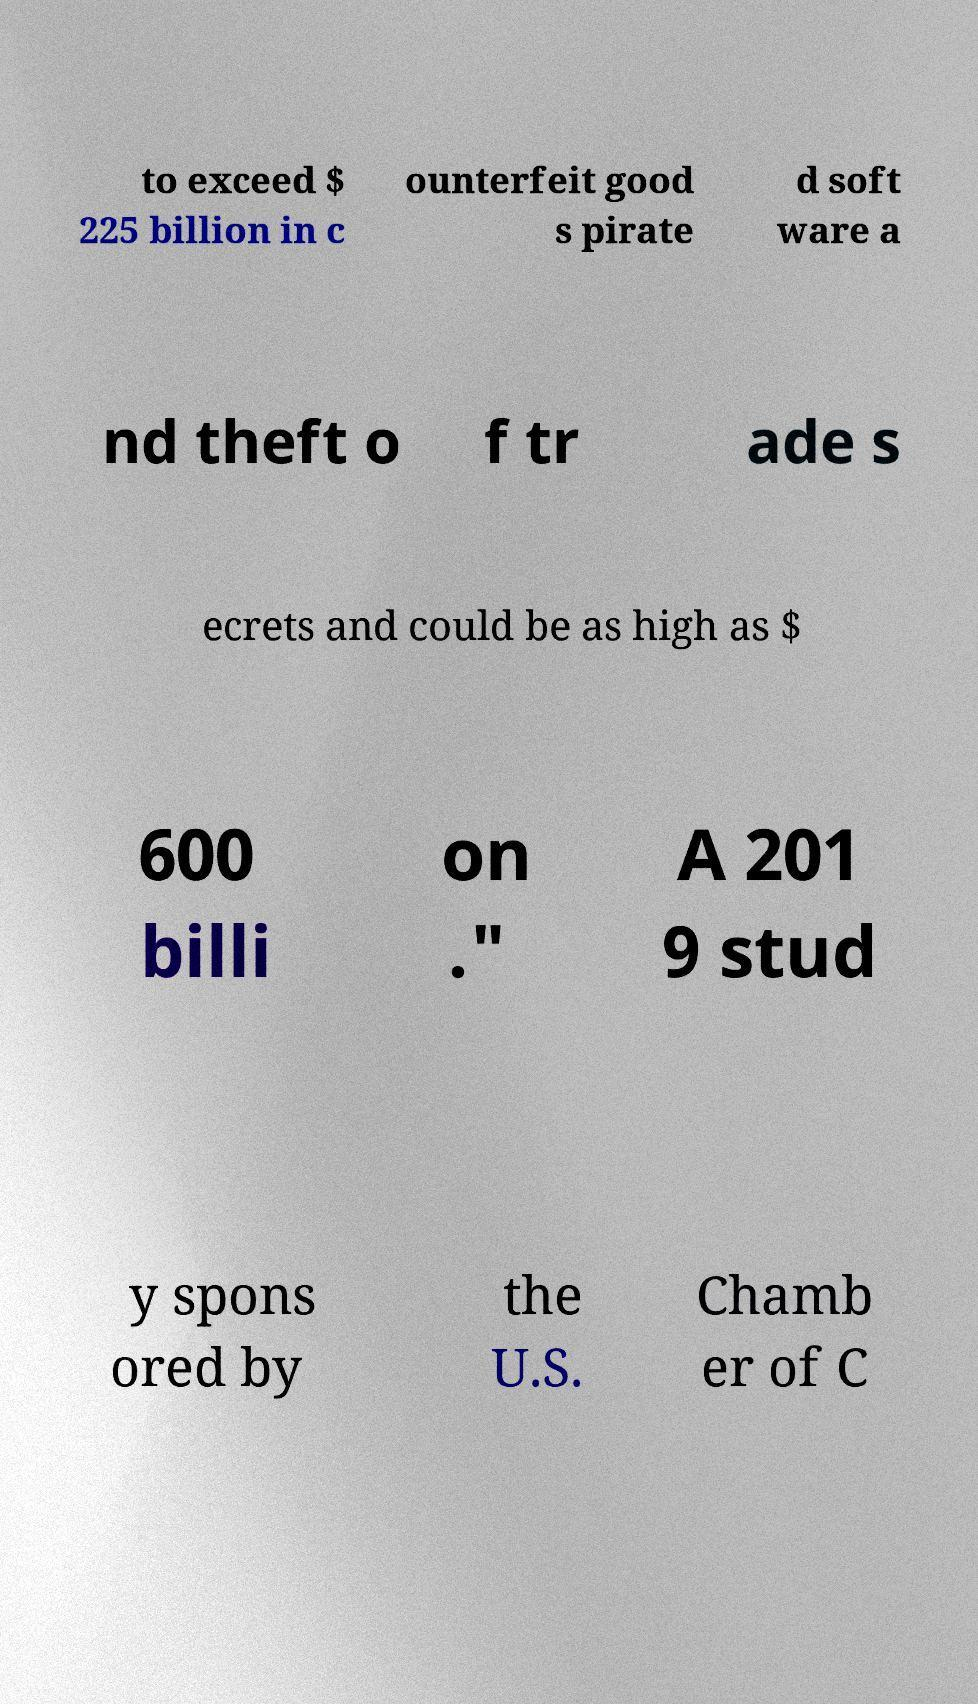Can you read and provide the text displayed in the image?This photo seems to have some interesting text. Can you extract and type it out for me? to exceed $ 225 billion in c ounterfeit good s pirate d soft ware a nd theft o f tr ade s ecrets and could be as high as $ 600 billi on ." A 201 9 stud y spons ored by the U.S. Chamb er of C 